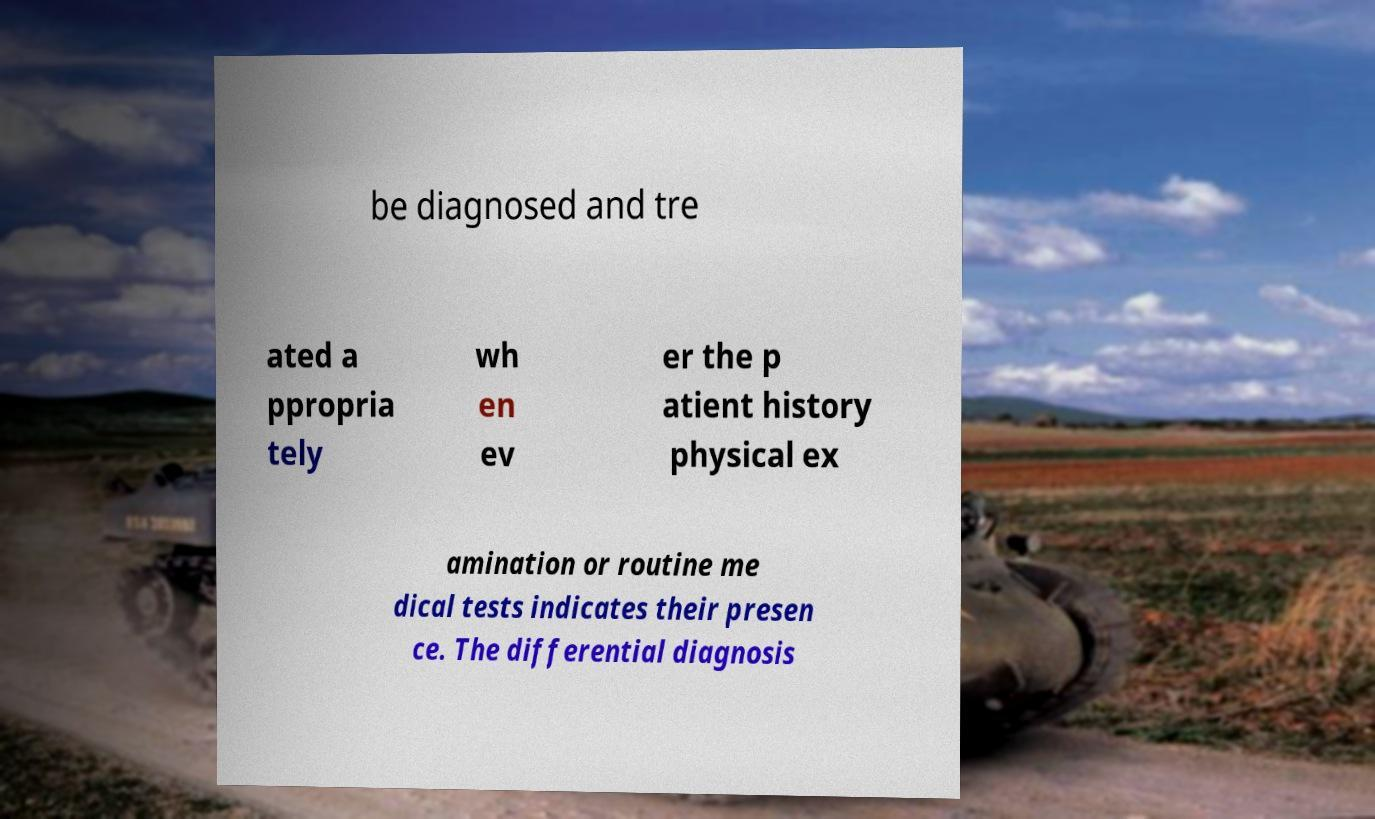Can you accurately transcribe the text from the provided image for me? be diagnosed and tre ated a ppropria tely wh en ev er the p atient history physical ex amination or routine me dical tests indicates their presen ce. The differential diagnosis 